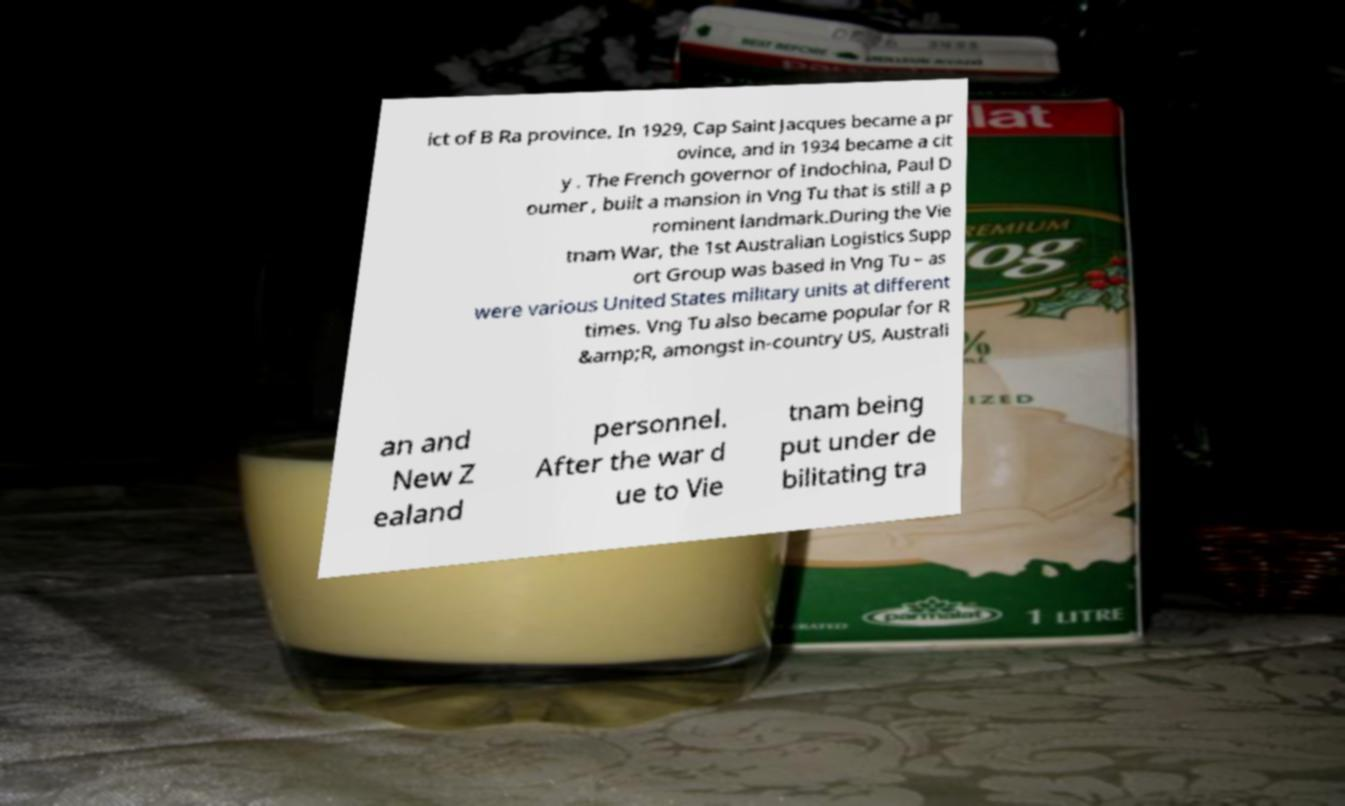Could you assist in decoding the text presented in this image and type it out clearly? ict of B Ra province. In 1929, Cap Saint Jacques became a pr ovince, and in 1934 became a cit y . The French governor of Indochina, Paul D oumer , built a mansion in Vng Tu that is still a p rominent landmark.During the Vie tnam War, the 1st Australian Logistics Supp ort Group was based in Vng Tu – as were various United States military units at different times. Vng Tu also became popular for R &amp;R, amongst in-country US, Australi an and New Z ealand personnel. After the war d ue to Vie tnam being put under de bilitating tra 